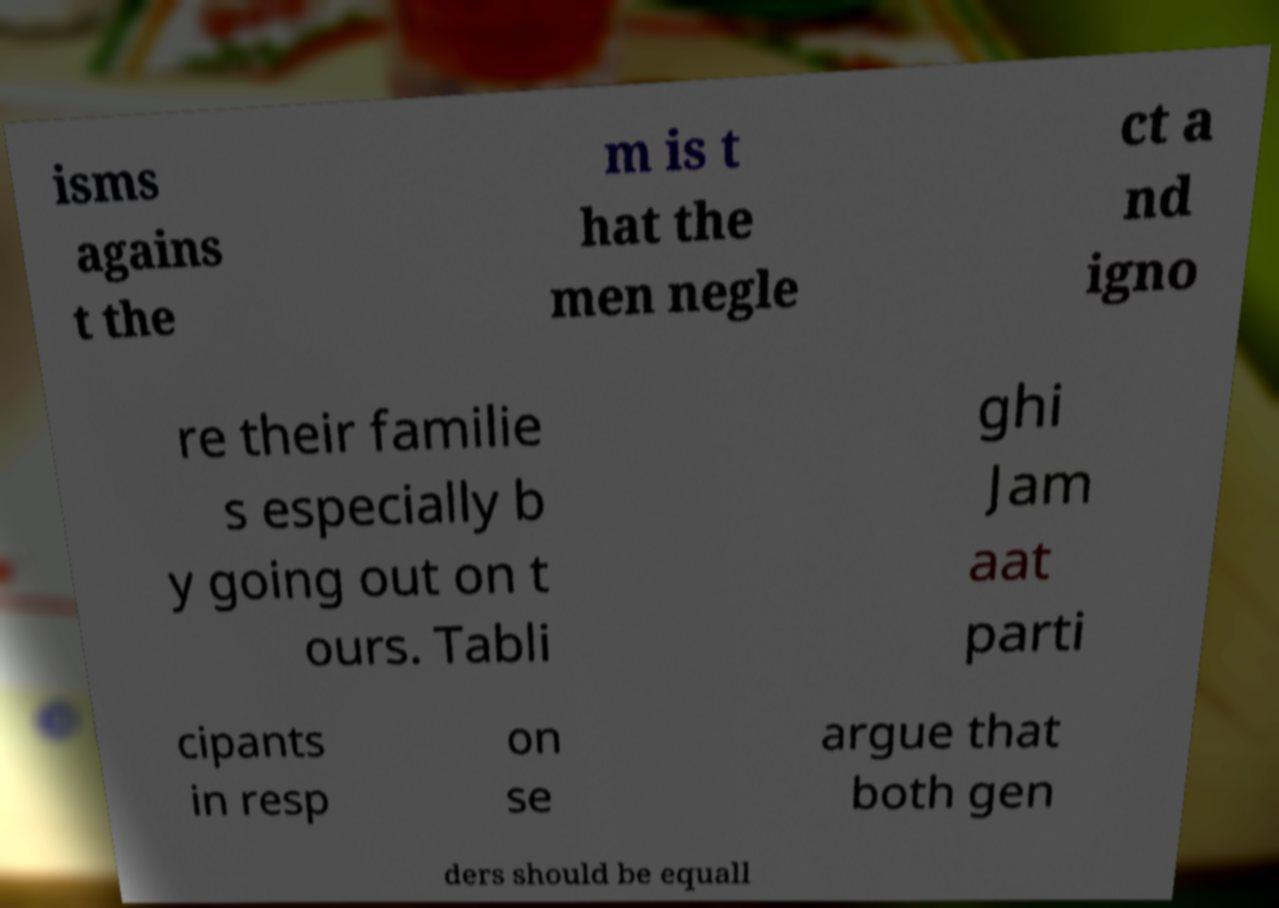I need the written content from this picture converted into text. Can you do that? isms agains t the m is t hat the men negle ct a nd igno re their familie s especially b y going out on t ours. Tabli ghi Jam aat parti cipants in resp on se argue that both gen ders should be equall 